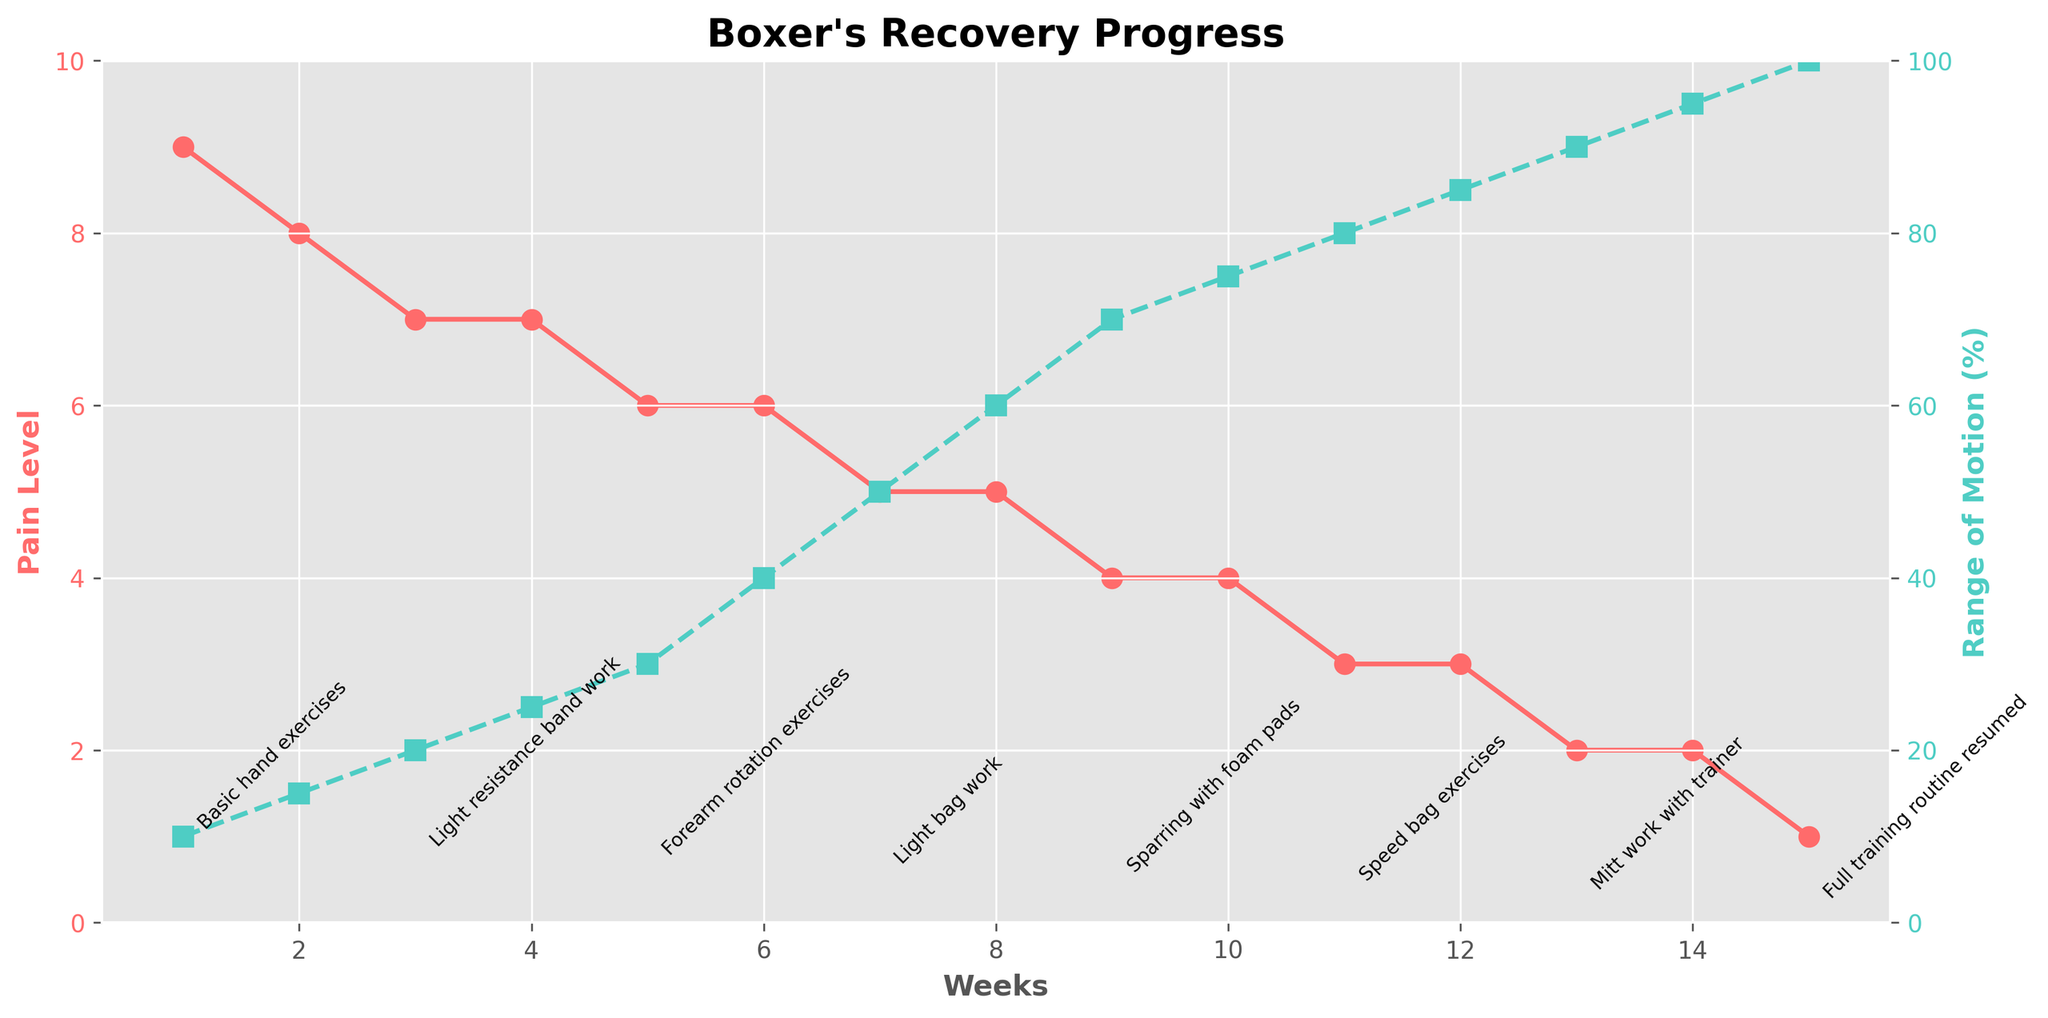What's the difference in pain level between the first and last weeks of recovery? Start with the pain level at week 1 which is 9 and at week 15 which is 1. Subtract the pain level at week 15 from week 1: 9 - 1 = 8.
Answer: 8 How does the range of motion at week 10 compare to week 5? At week 10, the range of motion is 75%. At week 5, it is 30%. Subtract the range of motion at week 5 from week 10: 75 - 30 = 45.
Answer: 45% In which week does the boxer's pain level drop below 5 for the first time? Identify the first week where the pain level is less than 5. This happens at week 9 where the pain level is 4.
Answer: Week 9 What's the average pain level reduction every week from week 1 through week 15? Find the total pain level reduction over the period which is 9 - 1 = 8. There are 14 weeks between week 1 and week 15. The average weekly reduction is 8 / 14 ≈ 0.57.
Answer: 0.57 Which week has the highest increase in range of motion compared to the previous week? Compare the range of motion percent increase at each week to the previous week. The biggest increase is from week 6 to week 7 (40% to 50%), which is a 10% increase.
Answer: Week 7 What visual attribute indicates the pain level data on the plot? The pain levels are indicated by the red line with circular markers.
Answer: Red line with circular markers At which week do the pain levels and range of motion become equal percentage-wise? Look for the week where the percentage of pain level and range of motion intersect or match. They never exactly intersect, but they get closest at week 4 with pain level 7 and range of motion 25%.
Answer: Never During which weeks does the pain level remain constant despite changes in physical therapy milestones? Identify periods with no change in the pain level. It remains constant from week 3 to week 4 and from week 6 to week 8.
Answer: Weeks 3-4 and 6-8 What is the range of motion improvement from week 2 to week 12? Subtract the range of motion at week 2 from that at week 12: 85% - 15% = 70%.
Answer: 70% How many weeks into the recovery does the boxer achieve 100% range of motion? The boxer achieves 100% range of motion at week 15.
Answer: Week 15 